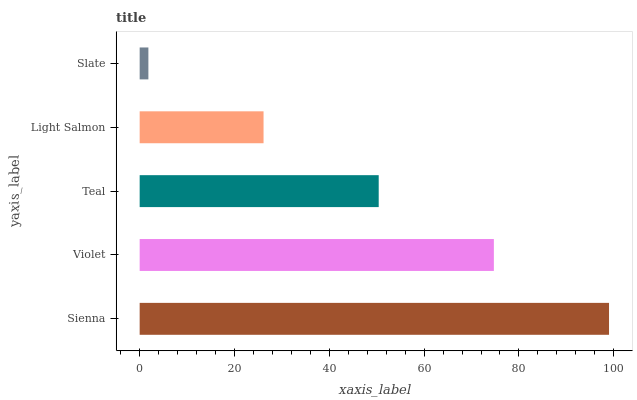Is Slate the minimum?
Answer yes or no. Yes. Is Sienna the maximum?
Answer yes or no. Yes. Is Violet the minimum?
Answer yes or no. No. Is Violet the maximum?
Answer yes or no. No. Is Sienna greater than Violet?
Answer yes or no. Yes. Is Violet less than Sienna?
Answer yes or no. Yes. Is Violet greater than Sienna?
Answer yes or no. No. Is Sienna less than Violet?
Answer yes or no. No. Is Teal the high median?
Answer yes or no. Yes. Is Teal the low median?
Answer yes or no. Yes. Is Violet the high median?
Answer yes or no. No. Is Light Salmon the low median?
Answer yes or no. No. 